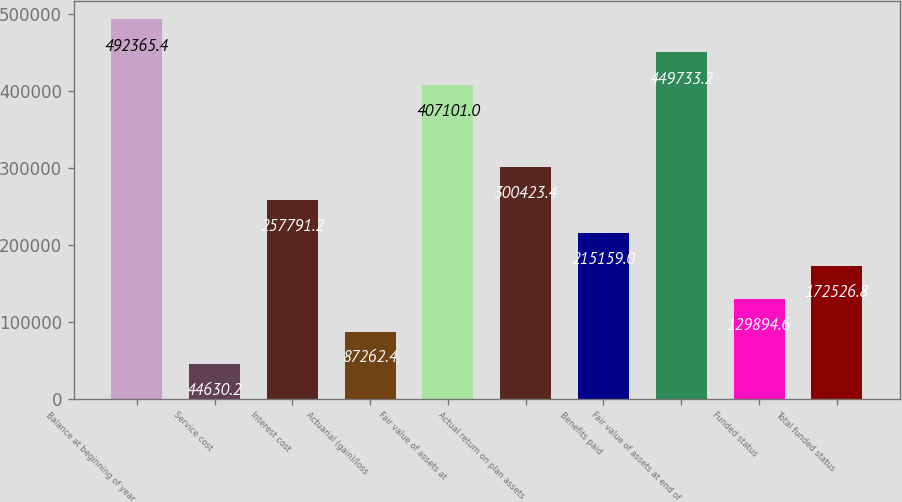<chart> <loc_0><loc_0><loc_500><loc_500><bar_chart><fcel>Balance at beginning of year<fcel>Service cost<fcel>Interest cost<fcel>Actuarial (gain)/loss<fcel>Fair value of assets at<fcel>Actual return on plan assets<fcel>Benefits paid<fcel>Fair value of assets at end of<fcel>Funded status<fcel>Total funded status<nl><fcel>492365<fcel>44630.2<fcel>257791<fcel>87262.4<fcel>407101<fcel>300423<fcel>215159<fcel>449733<fcel>129895<fcel>172527<nl></chart> 